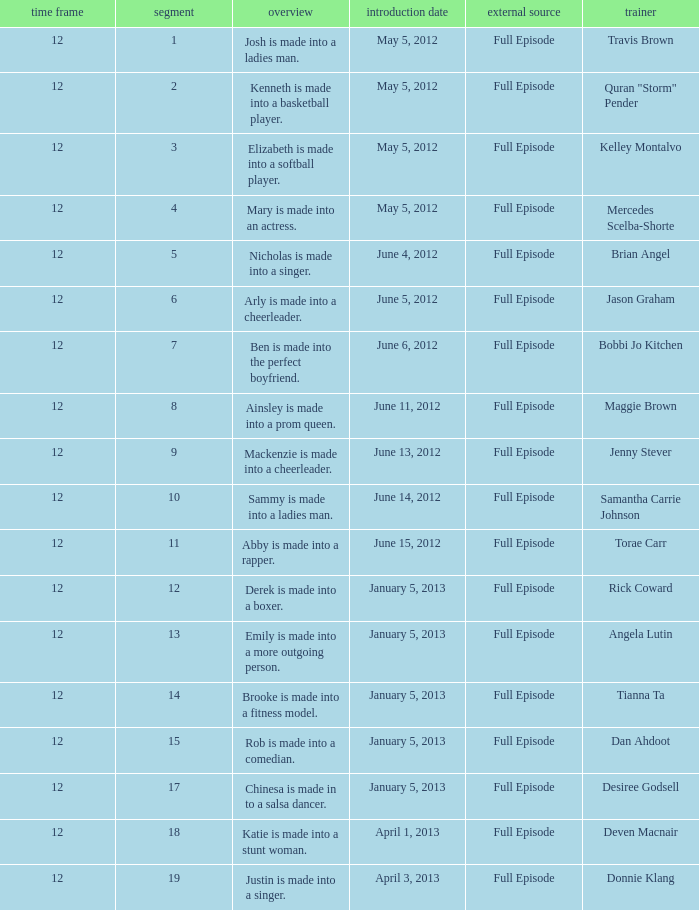Name the episode summary for travis brown Josh is made into a ladies man. 